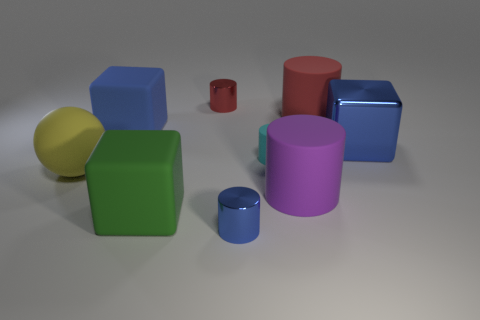Add 1 large things. How many objects exist? 10 Subtract all green rubber blocks. How many blocks are left? 2 Subtract all gray cylinders. How many blue cubes are left? 2 Subtract 2 cylinders. How many cylinders are left? 3 Subtract all cyan cylinders. How many cylinders are left? 4 Subtract all cubes. How many objects are left? 6 Subtract all yellow cylinders. Subtract all gray balls. How many cylinders are left? 5 Add 3 purple matte cylinders. How many purple matte cylinders are left? 4 Add 5 small cyan cylinders. How many small cyan cylinders exist? 6 Subtract 0 cyan spheres. How many objects are left? 9 